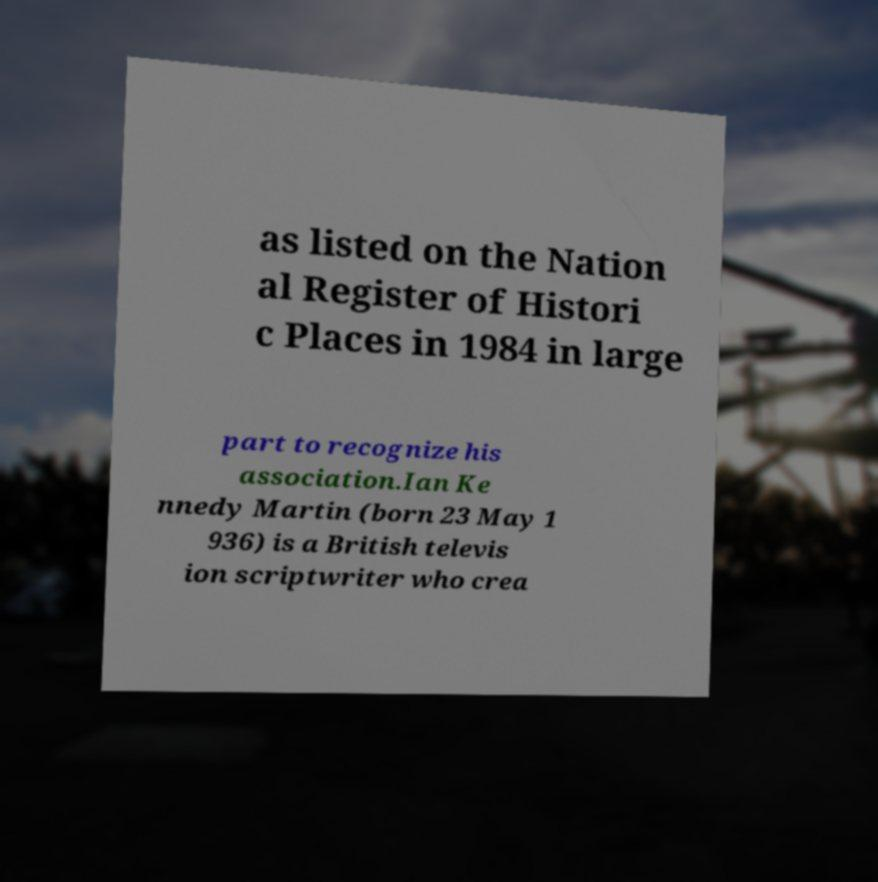Please identify and transcribe the text found in this image. as listed on the Nation al Register of Histori c Places in 1984 in large part to recognize his association.Ian Ke nnedy Martin (born 23 May 1 936) is a British televis ion scriptwriter who crea 